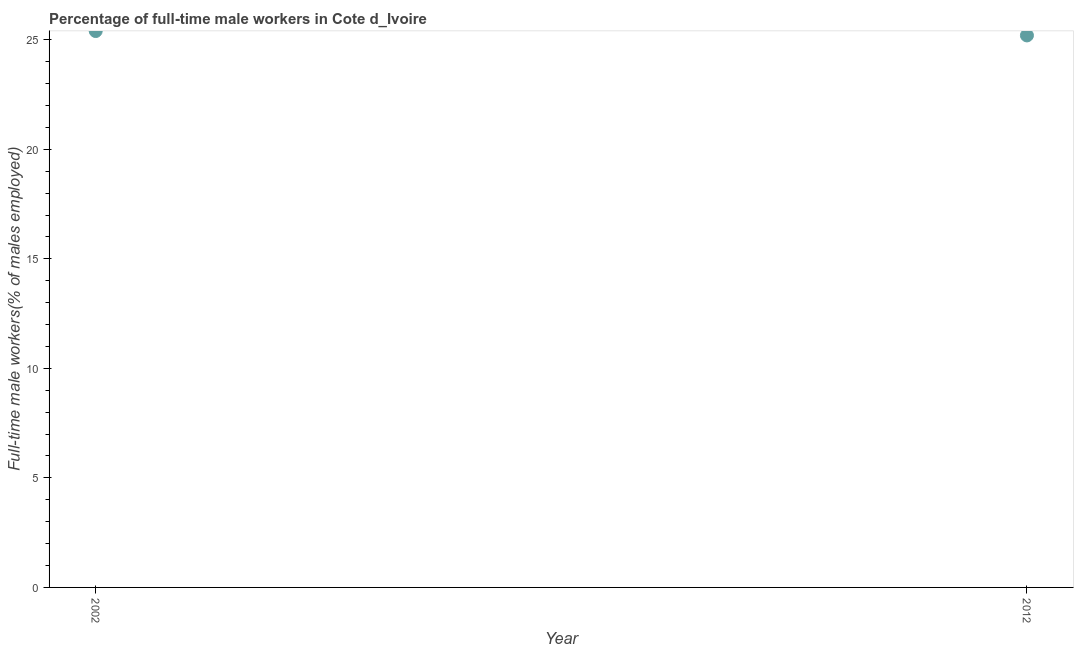What is the percentage of full-time male workers in 2012?
Make the answer very short. 25.2. Across all years, what is the maximum percentage of full-time male workers?
Ensure brevity in your answer.  25.4. Across all years, what is the minimum percentage of full-time male workers?
Offer a very short reply. 25.2. In which year was the percentage of full-time male workers maximum?
Keep it short and to the point. 2002. What is the sum of the percentage of full-time male workers?
Ensure brevity in your answer.  50.6. What is the difference between the percentage of full-time male workers in 2002 and 2012?
Ensure brevity in your answer.  0.2. What is the average percentage of full-time male workers per year?
Your answer should be very brief. 25.3. What is the median percentage of full-time male workers?
Provide a short and direct response. 25.3. In how many years, is the percentage of full-time male workers greater than 3 %?
Your answer should be very brief. 2. Do a majority of the years between 2012 and 2002 (inclusive) have percentage of full-time male workers greater than 21 %?
Keep it short and to the point. No. What is the ratio of the percentage of full-time male workers in 2002 to that in 2012?
Keep it short and to the point. 1.01. In how many years, is the percentage of full-time male workers greater than the average percentage of full-time male workers taken over all years?
Offer a very short reply. 1. Does the percentage of full-time male workers monotonically increase over the years?
Your response must be concise. No. What is the difference between two consecutive major ticks on the Y-axis?
Your response must be concise. 5. Are the values on the major ticks of Y-axis written in scientific E-notation?
Provide a short and direct response. No. Does the graph contain grids?
Your response must be concise. No. What is the title of the graph?
Offer a very short reply. Percentage of full-time male workers in Cote d_Ivoire. What is the label or title of the X-axis?
Your answer should be compact. Year. What is the label or title of the Y-axis?
Ensure brevity in your answer.  Full-time male workers(% of males employed). What is the Full-time male workers(% of males employed) in 2002?
Keep it short and to the point. 25.4. What is the Full-time male workers(% of males employed) in 2012?
Make the answer very short. 25.2. 